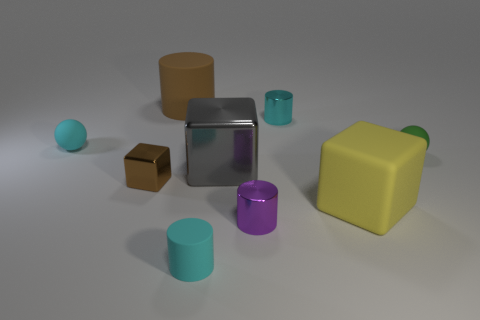Add 1 tiny rubber spheres. How many objects exist? 10 Subtract all cylinders. How many objects are left? 5 Subtract all gray rubber balls. Subtract all small purple metallic things. How many objects are left? 8 Add 2 green things. How many green things are left? 3 Add 4 blue metallic spheres. How many blue metallic spheres exist? 4 Subtract 1 purple cylinders. How many objects are left? 8 